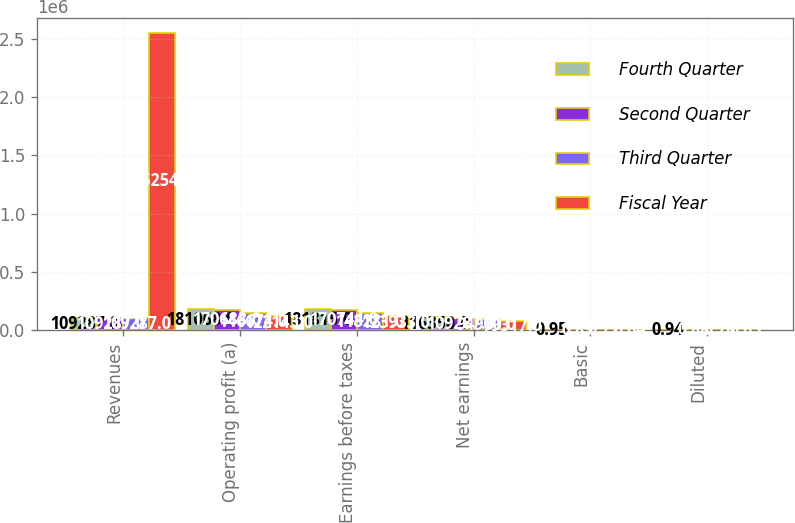Convert chart to OTSL. <chart><loc_0><loc_0><loc_500><loc_500><stacked_bar_chart><ecel><fcel>Revenues<fcel>Operating profit (a)<fcel>Earnings before taxes<fcel>Net earnings<fcel>Basic<fcel>Diluted<nl><fcel>Fourth Quarter<fcel>109287<fcel>181068<fcel>181815<fcel>116350<fcel>0.95<fcel>0.94<nl><fcel>Second Quarter<fcel>109287<fcel>170688<fcel>170744<fcel>109287<fcel>0.89<fcel>0.88<nl><fcel>Third Quarter<fcel>109287<fcel>146674<fcel>148281<fcel>94900<fcel>0.77<fcel>0.76<nl><fcel>Fiscal Year<fcel>2.55255e+06<fcel>122143<fcel>123933<fcel>79317<fcel>0.64<fcel>0.63<nl></chart> 